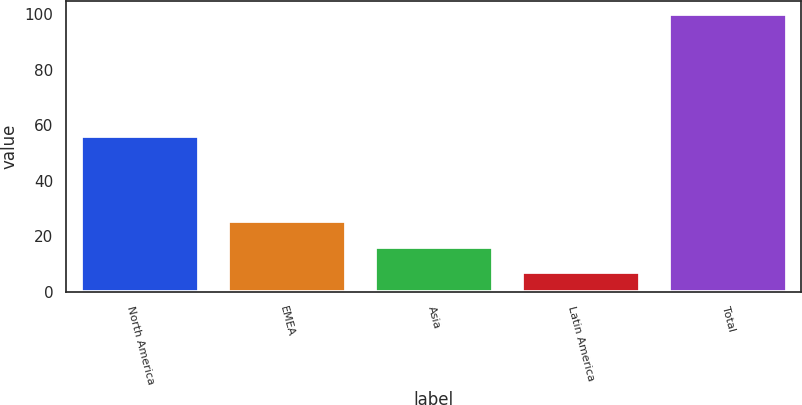<chart> <loc_0><loc_0><loc_500><loc_500><bar_chart><fcel>North America<fcel>EMEA<fcel>Asia<fcel>Latin America<fcel>Total<nl><fcel>56<fcel>25.6<fcel>16.3<fcel>7<fcel>100<nl></chart> 